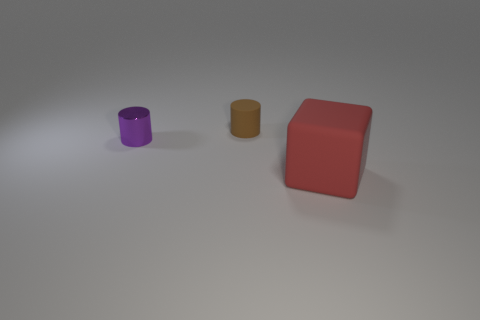Is the size of the rubber object that is on the left side of the large red cube the same as the matte thing in front of the purple metallic thing?
Provide a short and direct response. No. What number of other things are the same size as the rubber cylinder?
Give a very brief answer. 1. How many cylinders are on the left side of the small object that is behind the small metal object?
Your response must be concise. 1. Is the number of tiny brown cylinders in front of the small purple cylinder less than the number of tiny brown rubber cylinders?
Provide a short and direct response. Yes. There is a rubber object in front of the rubber object behind the small cylinder that is to the left of the small brown matte object; what is its shape?
Ensure brevity in your answer.  Cube. Do the red rubber object and the metal thing have the same shape?
Your answer should be very brief. No. How many other things are the same shape as the shiny thing?
Your response must be concise. 1. What color is the other shiny thing that is the same size as the brown thing?
Make the answer very short. Purple. Is the number of tiny purple cylinders that are on the left side of the large red rubber block the same as the number of purple things?
Ensure brevity in your answer.  Yes. The object that is in front of the tiny brown cylinder and on the left side of the red object has what shape?
Offer a terse response. Cylinder. 